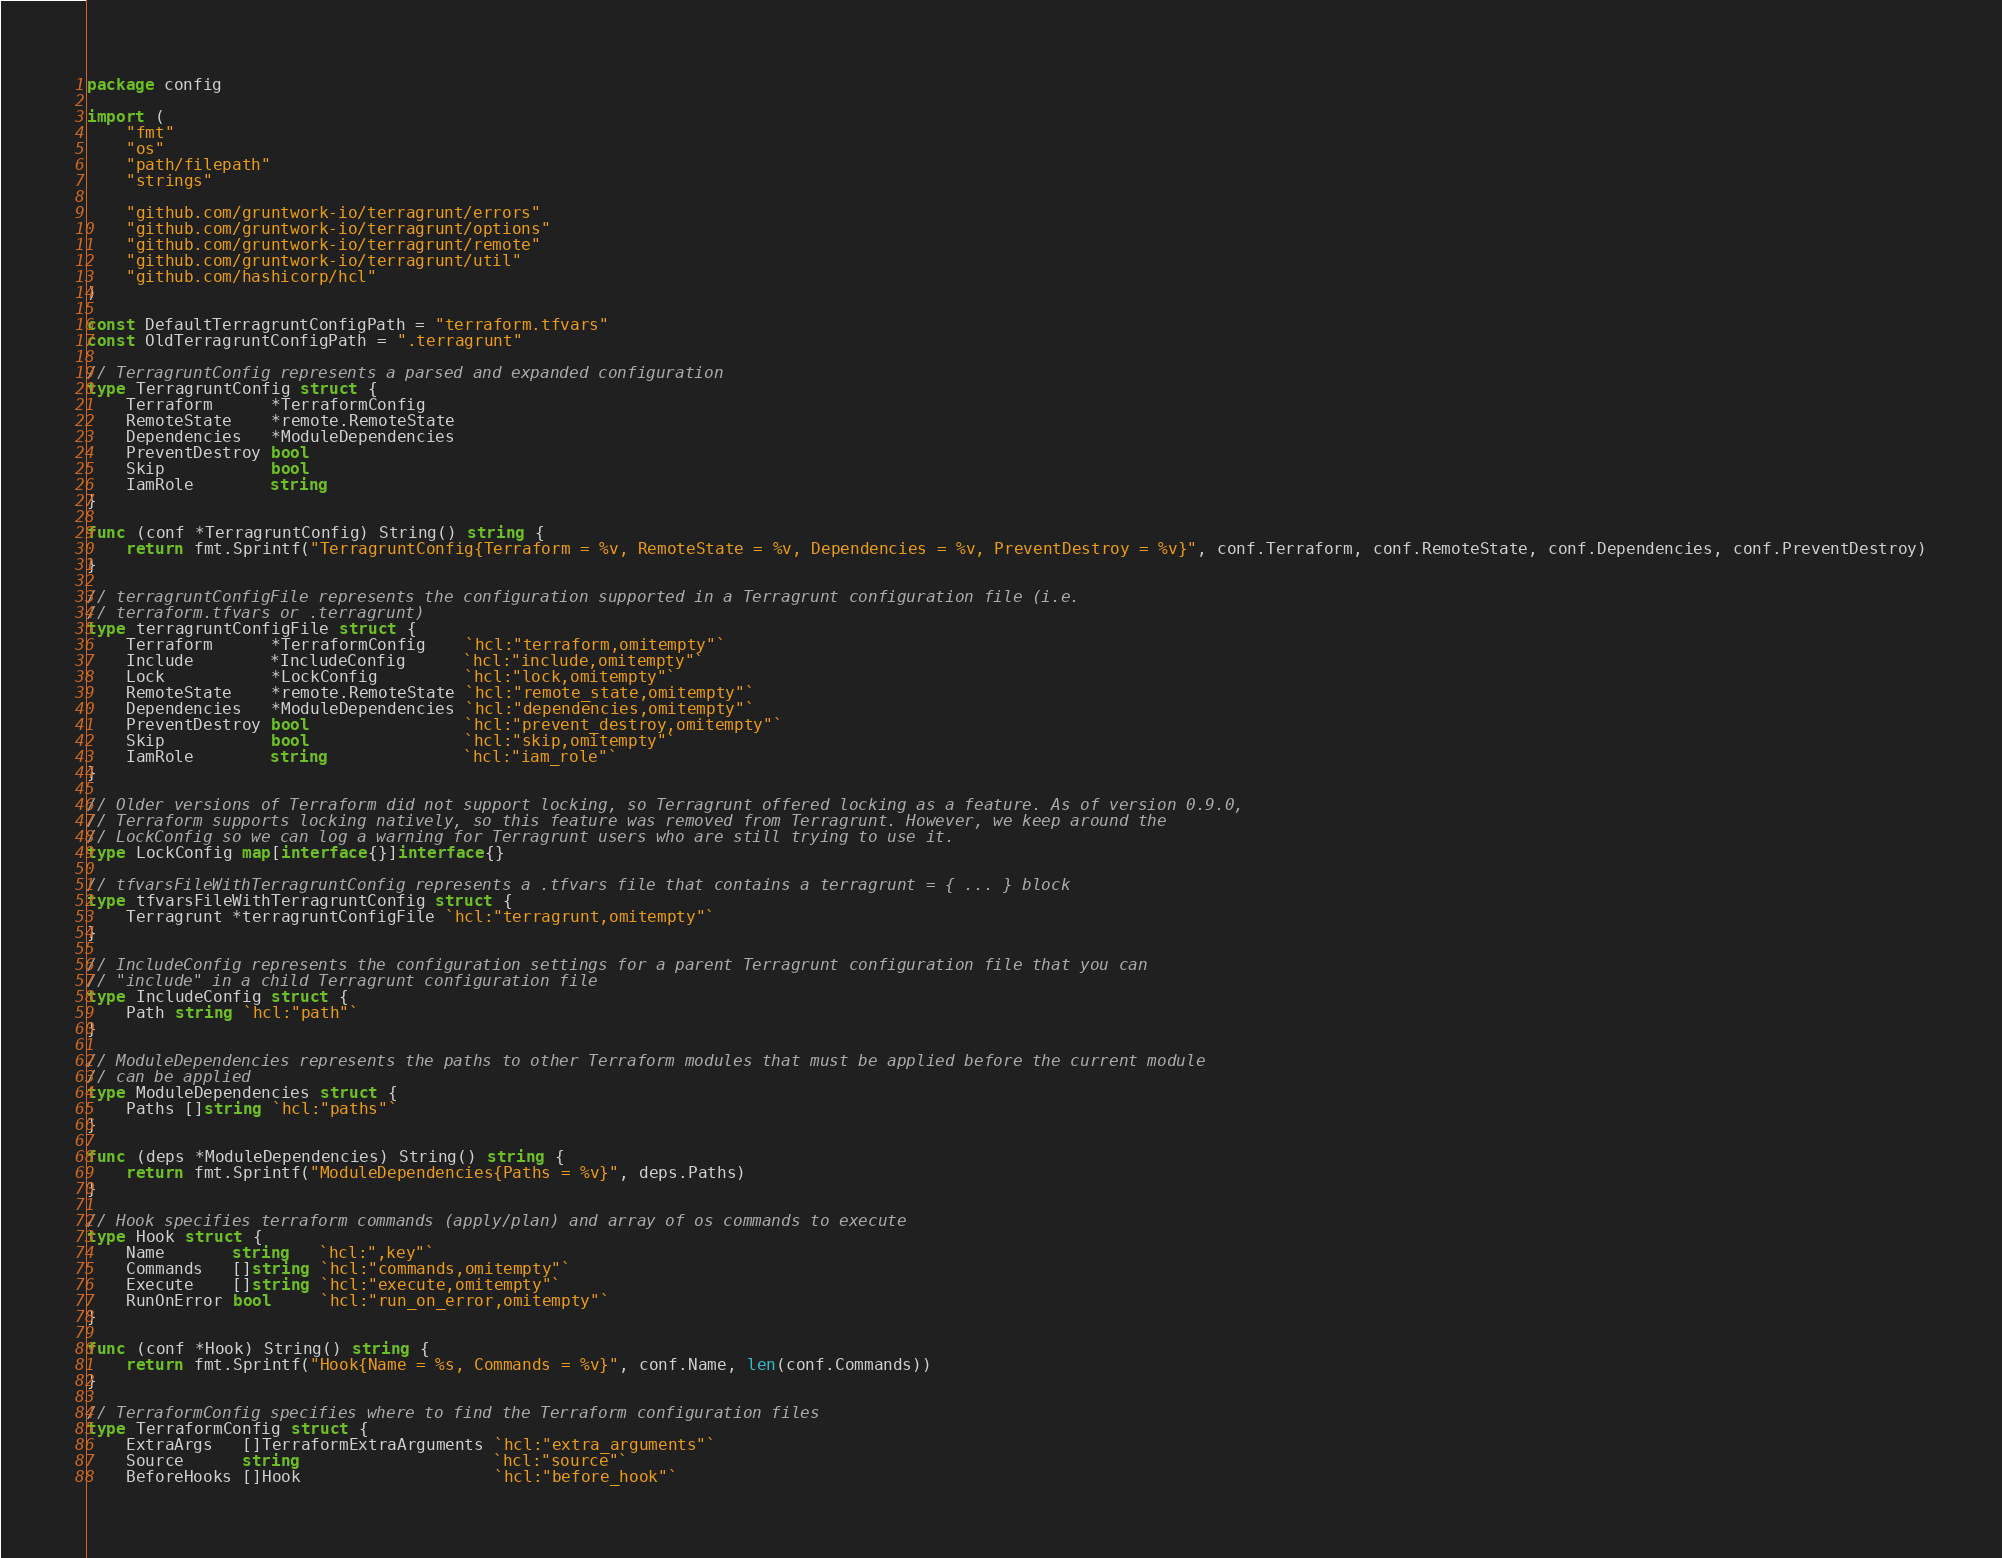<code> <loc_0><loc_0><loc_500><loc_500><_Go_>package config

import (
	"fmt"
	"os"
	"path/filepath"
	"strings"

	"github.com/gruntwork-io/terragrunt/errors"
	"github.com/gruntwork-io/terragrunt/options"
	"github.com/gruntwork-io/terragrunt/remote"
	"github.com/gruntwork-io/terragrunt/util"
	"github.com/hashicorp/hcl"
)

const DefaultTerragruntConfigPath = "terraform.tfvars"
const OldTerragruntConfigPath = ".terragrunt"

// TerragruntConfig represents a parsed and expanded configuration
type TerragruntConfig struct {
	Terraform      *TerraformConfig
	RemoteState    *remote.RemoteState
	Dependencies   *ModuleDependencies
	PreventDestroy bool
	Skip           bool
	IamRole        string
}

func (conf *TerragruntConfig) String() string {
	return fmt.Sprintf("TerragruntConfig{Terraform = %v, RemoteState = %v, Dependencies = %v, PreventDestroy = %v}", conf.Terraform, conf.RemoteState, conf.Dependencies, conf.PreventDestroy)
}

// terragruntConfigFile represents the configuration supported in a Terragrunt configuration file (i.e.
// terraform.tfvars or .terragrunt)
type terragruntConfigFile struct {
	Terraform      *TerraformConfig    `hcl:"terraform,omitempty"`
	Include        *IncludeConfig      `hcl:"include,omitempty"`
	Lock           *LockConfig         `hcl:"lock,omitempty"`
	RemoteState    *remote.RemoteState `hcl:"remote_state,omitempty"`
	Dependencies   *ModuleDependencies `hcl:"dependencies,omitempty"`
	PreventDestroy bool                `hcl:"prevent_destroy,omitempty"`
	Skip           bool                `hcl:"skip,omitempty"`
	IamRole        string              `hcl:"iam_role"`
}

// Older versions of Terraform did not support locking, so Terragrunt offered locking as a feature. As of version 0.9.0,
// Terraform supports locking natively, so this feature was removed from Terragrunt. However, we keep around the
// LockConfig so we can log a warning for Terragrunt users who are still trying to use it.
type LockConfig map[interface{}]interface{}

// tfvarsFileWithTerragruntConfig represents a .tfvars file that contains a terragrunt = { ... } block
type tfvarsFileWithTerragruntConfig struct {
	Terragrunt *terragruntConfigFile `hcl:"terragrunt,omitempty"`
}

// IncludeConfig represents the configuration settings for a parent Terragrunt configuration file that you can
// "include" in a child Terragrunt configuration file
type IncludeConfig struct {
	Path string `hcl:"path"`
}

// ModuleDependencies represents the paths to other Terraform modules that must be applied before the current module
// can be applied
type ModuleDependencies struct {
	Paths []string `hcl:"paths"`
}

func (deps *ModuleDependencies) String() string {
	return fmt.Sprintf("ModuleDependencies{Paths = %v}", deps.Paths)
}

// Hook specifies terraform commands (apply/plan) and array of os commands to execute
type Hook struct {
	Name       string   `hcl:",key"`
	Commands   []string `hcl:"commands,omitempty"`
	Execute    []string `hcl:"execute,omitempty"`
	RunOnError bool     `hcl:"run_on_error,omitempty"`
}

func (conf *Hook) String() string {
	return fmt.Sprintf("Hook{Name = %s, Commands = %v}", conf.Name, len(conf.Commands))
}

// TerraformConfig specifies where to find the Terraform configuration files
type TerraformConfig struct {
	ExtraArgs   []TerraformExtraArguments `hcl:"extra_arguments"`
	Source      string                    `hcl:"source"`
	BeforeHooks []Hook                    `hcl:"before_hook"`</code> 